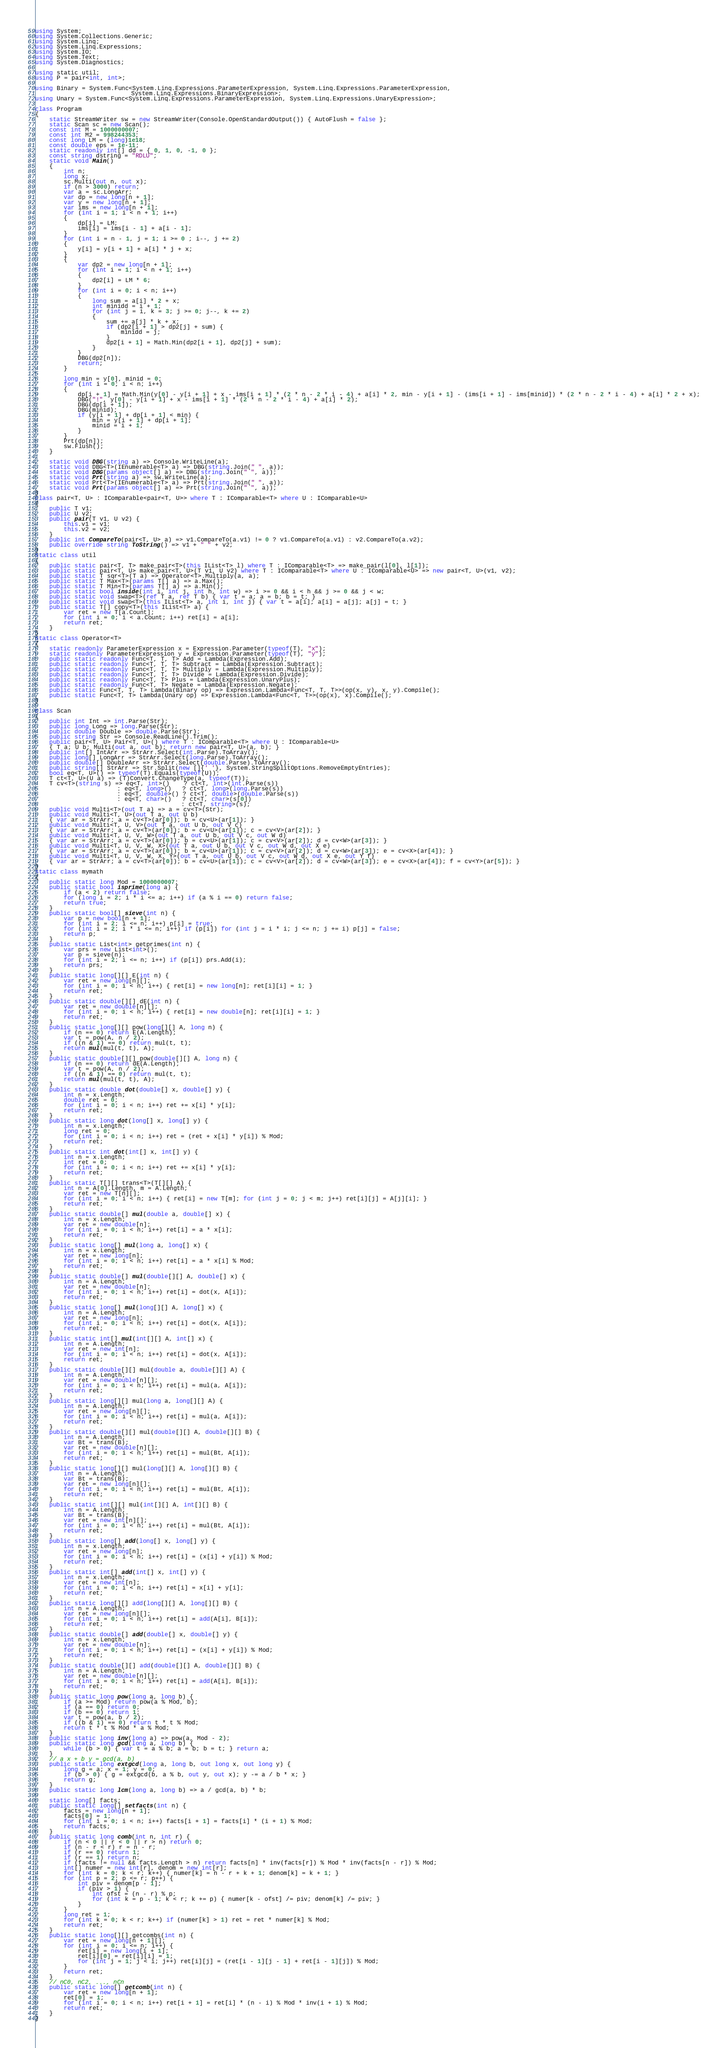<code> <loc_0><loc_0><loc_500><loc_500><_C#_>using System;
using System.Collections.Generic;
using System.Linq;
using System.Linq.Expressions;
using System.IO;
using System.Text;
using System.Diagnostics;

using static util;
using P = pair<int, int>;

using Binary = System.Func<System.Linq.Expressions.ParameterExpression, System.Linq.Expressions.ParameterExpression,
                           System.Linq.Expressions.BinaryExpression>;
using Unary = System.Func<System.Linq.Expressions.ParameterExpression, System.Linq.Expressions.UnaryExpression>;

class Program
{
    static StreamWriter sw = new StreamWriter(Console.OpenStandardOutput()) { AutoFlush = false };
    static Scan sc = new Scan();
    const int M = 1000000007;
    const int M2 = 998244353;
    const long LM = (long)1e18;
    const double eps = 1e-11;
    static readonly int[] dd = { 0, 1, 0, -1, 0 };
    const string dstring = "RDLU";
    static void Main()
    {
        int n;
        long x;
        sc.Multi(out n, out x);
        if (n > 3000) return;
        var a = sc.LongArr;
        var dp = new long[n + 1];
        var y = new long[n + 1];
        var ims = new long[n + 1];
        for (int i = 1; i < n + 1; i++)
        {
            dp[i] = LM;
            ims[i] = ims[i - 1] + a[i - 1];
        }
        for (int i = n - 1, j = 1; i >= 0 ; i--, j += 2)
        {
            y[i] = y[i + 1] + a[i] * j + x;
        }
        {
            var dp2 = new long[n + 1];
            for (int i = 1; i < n + 1; i++)
            {
                dp2[i] = LM * 6;
            }
            for (int i = 0; i < n; i++)
            {
                long sum = a[i] * 2 + x;
                int minidd = i + 1;
                for (int j = i, k = 3; j >= 0; j--, k += 2)
                {
                    sum += a[j] * k + x;
                    if (dp2[i + 1] > dp2[j] + sum) {
                        minidd = j;
                    }
                    dp2[i + 1] = Math.Min(dp2[i + 1], dp2[j] + sum);
                }
            }
            DBG(dp2[n]);
            return;
        }

        long min = y[0], minid = 0;
        for (int i = 0; i < n; i++)
        {
            dp[i + 1] = Math.Min(y[0] - y[i + 1] + x - ims[i + 1] * (2 * n - 2 * i - 4) + a[i] * 2, min - y[i + 1] - (ims[i + 1] - ims[minid]) * (2 * n - 2 * i - 4) + a[i] * 2 + x);
            DBG("!", y[0] - y[i + 1] + x - ims[i + 1] * (2 * n - 2 * i - 4) + a[i] * 2);
            DBG(dp[i + 1]);
            DBG(minid);
            if (y[i + 1] + dp[i + 1] < min) {
                min = y[i + 1] + dp[i + 1];
                minid = i + 1;
            }
        }
        Prt(dp[n]);
        sw.Flush();
    }

    static void DBG(string a) => Console.WriteLine(a);
    static void DBG<T>(IEnumerable<T> a) => DBG(string.Join(" ", a));
    static void DBG(params object[] a) => DBG(string.Join(" ", a));
    static void Prt(string a) => sw.WriteLine(a);
    static void Prt<T>(IEnumerable<T> a) => Prt(string.Join(" ", a));
    static void Prt(params object[] a) => Prt(string.Join(" ", a));
}
class pair<T, U> : IComparable<pair<T, U>> where T : IComparable<T> where U : IComparable<U>
{
    public T v1;
    public U v2;
    public pair(T v1, U v2) {
        this.v1 = v1;
        this.v2 = v2;
    }
    public int CompareTo(pair<T, U> a) => v1.CompareTo(a.v1) != 0 ? v1.CompareTo(a.v1) : v2.CompareTo(a.v2);
    public override string ToString() => v1 + " " + v2;
}
static class util
{
    public static pair<T, T> make_pair<T>(this IList<T> l) where T : IComparable<T> => make_pair(l[0], l[1]);
    public static pair<T, U> make_pair<T, U>(T v1, U v2) where T : IComparable<T> where U : IComparable<U> => new pair<T, U>(v1, v2);
    public static T sqr<T>(T a) => Operator<T>.Multiply(a, a);
    public static T Max<T>(params T[] a) => a.Max();
    public static T Min<T>(params T[] a) => a.Min();
    public static bool inside(int i, int j, int h, int w) => i >= 0 && i < h && j >= 0 && j < w;
    public static void swap<T>(ref T a, ref T b) { var t = a; a = b; b = t; }
    public static void swap<T>(this IList<T> a, int i, int j) { var t = a[i]; a[i] = a[j]; a[j] = t; }
    public static T[] copy<T>(this IList<T> a) {
        var ret = new T[a.Count];
        for (int i = 0; i < a.Count; i++) ret[i] = a[i];
        return ret;
    }
}
static class Operator<T>
{
    static readonly ParameterExpression x = Expression.Parameter(typeof(T), "x");
    static readonly ParameterExpression y = Expression.Parameter(typeof(T), "y");
    public static readonly Func<T, T, T> Add = Lambda(Expression.Add);
    public static readonly Func<T, T, T> Subtract = Lambda(Expression.Subtract);
    public static readonly Func<T, T, T> Multiply = Lambda(Expression.Multiply);
    public static readonly Func<T, T, T> Divide = Lambda(Expression.Divide);
    public static readonly Func<T, T> Plus = Lambda(Expression.UnaryPlus);
    public static readonly Func<T, T> Negate = Lambda(Expression.Negate);
    public static Func<T, T, T> Lambda(Binary op) => Expression.Lambda<Func<T, T, T>>(op(x, y), x, y).Compile();
    public static Func<T, T> Lambda(Unary op) => Expression.Lambda<Func<T, T>>(op(x), x).Compile();
}

class Scan
{
    public int Int => int.Parse(Str);
    public long Long => long.Parse(Str);
    public double Double => double.Parse(Str);
    public string Str => Console.ReadLine().Trim();
    public pair<T, U> Pair<T, U>() where T : IComparable<T> where U : IComparable<U>
    { T a; U b; Multi(out a, out b); return new pair<T, U>(a, b); }
    public int[] IntArr => StrArr.Select(int.Parse).ToArray();
    public long[] LongArr => StrArr.Select(long.Parse).ToArray();
    public double[] DoubleArr => StrArr.Select(double.Parse).ToArray();
    public string[] StrArr => Str.Split(new []{' '}, System.StringSplitOptions.RemoveEmptyEntries);
    bool eq<T, U>() => typeof(T).Equals(typeof(U));
    T ct<T, U>(U a) => (T)Convert.ChangeType(a, typeof(T));
    T cv<T>(string s) => eq<T, int>()    ? ct<T, int>(int.Parse(s))
                       : eq<T, long>()   ? ct<T, long>(long.Parse(s))
                       : eq<T, double>() ? ct<T, double>(double.Parse(s))
                       : eq<T, char>()   ? ct<T, char>(s[0])
                                         : ct<T, string>(s);
    public void Multi<T>(out T a) => a = cv<T>(Str);
    public void Multi<T, U>(out T a, out U b)
    { var ar = StrArr; a = cv<T>(ar[0]); b = cv<U>(ar[1]); }
    public void Multi<T, U, V>(out T a, out U b, out V c)
    { var ar = StrArr; a = cv<T>(ar[0]); b = cv<U>(ar[1]); c = cv<V>(ar[2]); }
    public void Multi<T, U, V, W>(out T a, out U b, out V c, out W d)
    { var ar = StrArr; a = cv<T>(ar[0]); b = cv<U>(ar[1]); c = cv<V>(ar[2]); d = cv<W>(ar[3]); }
    public void Multi<T, U, V, W, X>(out T a, out U b, out V c, out W d, out X e)
    { var ar = StrArr; a = cv<T>(ar[0]); b = cv<U>(ar[1]); c = cv<V>(ar[2]); d = cv<W>(ar[3]); e = cv<X>(ar[4]); }
    public void Multi<T, U, V, W, X, Y>(out T a, out U b, out V c, out W d, out X e, out Y f)
    { var ar = StrArr; a = cv<T>(ar[0]); b = cv<U>(ar[1]); c = cv<V>(ar[2]); d = cv<W>(ar[3]); e = cv<X>(ar[4]); f = cv<Y>(ar[5]); }
}
static class mymath
{
    public static long Mod = 1000000007;
    public static bool isprime(long a) {
        if (a < 2) return false;
        for (long i = 2; i * i <= a; i++) if (a % i == 0) return false;
        return true;
    }
    public static bool[] sieve(int n) {
        var p = new bool[n + 1];
        for (int i = 2; i <= n; i++) p[i] = true;
        for (int i = 2; i * i <= n; i++) if (p[i]) for (int j = i * i; j <= n; j += i) p[j] = false;
        return p;
    }
    public static List<int> getprimes(int n) {
        var prs = new List<int>();
        var p = sieve(n);
        for (int i = 2; i <= n; i++) if (p[i]) prs.Add(i);
        return prs;
    }
    public static long[][] E(int n) {
        var ret = new long[n][];
        for (int i = 0; i < n; i++) { ret[i] = new long[n]; ret[i][i] = 1; }
        return ret;
    }
    public static double[][] dE(int n) {
        var ret = new double[n][];
        for (int i = 0; i < n; i++) { ret[i] = new double[n]; ret[i][i] = 1; }
        return ret;
    }
    public static long[][] pow(long[][] A, long n) {
        if (n == 0) return E(A.Length);
        var t = pow(A, n / 2);
        if ((n & 1) == 0) return mul(t, t);
        return mul(mul(t, t), A);
    }
    public static double[][] pow(double[][] A, long n) {
        if (n == 0) return dE(A.Length);
        var t = pow(A, n / 2);
        if ((n & 1) == 0) return mul(t, t);
        return mul(mul(t, t), A);
    }
    public static double dot(double[] x, double[] y) {
        int n = x.Length;
        double ret = 0;
        for (int i = 0; i < n; i++) ret += x[i] * y[i];
        return ret;
    }
    public static long dot(long[] x, long[] y) {
        int n = x.Length;
        long ret = 0;
        for (int i = 0; i < n; i++) ret = (ret + x[i] * y[i]) % Mod;
        return ret;
    }
    public static int dot(int[] x, int[] y) {
        int n = x.Length;
        int ret = 0;
        for (int i = 0; i < n; i++) ret += x[i] * y[i];
        return ret;
    }
    public static T[][] trans<T>(T[][] A) {
        int n = A[0].Length, m = A.Length;
        var ret = new T[n][];
        for (int i = 0; i < n; i++) { ret[i] = new T[m]; for (int j = 0; j < m; j++) ret[i][j] = A[j][i]; }
        return ret;
    }
    public static double[] mul(double a, double[] x) {
        int n = x.Length;
        var ret = new double[n];
        for (int i = 0; i < n; i++) ret[i] = a * x[i];
        return ret;
    }
    public static long[] mul(long a, long[] x) {
        int n = x.Length;
        var ret = new long[n];
        for (int i = 0; i < n; i++) ret[i] = a * x[i] % Mod;
        return ret;
    }
    public static double[] mul(double[][] A, double[] x) {
        int n = A.Length;
        var ret = new double[n];
        for (int i = 0; i < n; i++) ret[i] = dot(x, A[i]);
        return ret;
    }
    public static long[] mul(long[][] A, long[] x) {
        int n = A.Length;
        var ret = new long[n];
        for (int i = 0; i < n; i++) ret[i] = dot(x, A[i]);
        return ret;
    }
    public static int[] mul(int[][] A, int[] x) {
        int n = A.Length;
        var ret = new int[n];
        for (int i = 0; i < n; i++) ret[i] = dot(x, A[i]);
        return ret;
    }
    public static double[][] mul(double a, double[][] A) {
        int n = A.Length;
        var ret = new double[n][];
        for (int i = 0; i < n; i++) ret[i] = mul(a, A[i]);
        return ret;
    }
    public static long[][] mul(long a, long[][] A) {
        int n = A.Length;
        var ret = new long[n][];
        for (int i = 0; i < n; i++) ret[i] = mul(a, A[i]);
        return ret;
    }
    public static double[][] mul(double[][] A, double[][] B) {
        int n = A.Length;
        var Bt = trans(B);
        var ret = new double[n][];
        for (int i = 0; i < n; i++) ret[i] = mul(Bt, A[i]);
        return ret;
    }
    public static long[][] mul(long[][] A, long[][] B) {
        int n = A.Length;
        var Bt = trans(B);
        var ret = new long[n][];
        for (int i = 0; i < n; i++) ret[i] = mul(Bt, A[i]);
        return ret;
    }
    public static int[][] mul(int[][] A, int[][] B) {
        int n = A.Length;
        var Bt = trans(B);
        var ret = new int[n][];
        for (int i = 0; i < n; i++) ret[i] = mul(Bt, A[i]);
        return ret;
    }
    public static long[] add(long[] x, long[] y) {
        int n = x.Length;
        var ret = new long[n];
        for (int i = 0; i < n; i++) ret[i] = (x[i] + y[i]) % Mod;
        return ret;
    }
    public static int[] add(int[] x, int[] y) {
        int n = x.Length;
        var ret = new int[n];
        for (int i = 0; i < n; i++) ret[i] = x[i] + y[i];
        return ret;
    }
    public static long[][] add(long[][] A, long[][] B) {
        int n = A.Length;
        var ret = new long[n][];
        for (int i = 0; i < n; i++) ret[i] = add(A[i], B[i]);
        return ret;
    }
    public static double[] add(double[] x, double[] y) {
        int n = x.Length;
        var ret = new double[n];
        for (int i = 0; i < n; i++) ret[i] = (x[i] + y[i]) % Mod;
        return ret;
    }
    public static double[][] add(double[][] A, double[][] B) {
        int n = A.Length;
        var ret = new double[n][];
        for (int i = 0; i < n; i++) ret[i] = add(A[i], B[i]);
        return ret;
    }
    public static long pow(long a, long b) {
        if (a >= Mod) return pow(a % Mod, b);
        if (a == 0) return 0;
        if (b == 0) return 1;
        var t = pow(a, b / 2);
        if ((b & 1) == 0) return t * t % Mod;
        return t * t % Mod * a % Mod;
    }
    public static long inv(long a) => pow(a, Mod - 2);
    public static long gcd(long a, long b) {
        while (b > 0) { var t = a % b; a = b; b = t; } return a;
    }
    // a x + b y = gcd(a, b)
    public static long extgcd(long a, long b, out long x, out long y) {
        long g = a; x = 1; y = 0;
        if (b > 0) { g = extgcd(b, a % b, out y, out x); y -= a / b * x; }
        return g;
    }
    public static long lcm(long a, long b) => a / gcd(a, b) * b;

    static long[] facts;
    public static long[] setfacts(int n) {
        facts = new long[n + 1];
        facts[0] = 1;
        for (int i = 0; i < n; i++) facts[i + 1] = facts[i] * (i + 1) % Mod;
        return facts;
    }
    public static long comb(int n, int r) {
        if (n < 0 || r < 0 || r > n) return 0;
        if (n - r < r) r = n - r;
        if (r == 0) return 1;
        if (r == 1) return n;
        if (facts != null && facts.Length > n) return facts[n] * inv(facts[r]) % Mod * inv(facts[n - r]) % Mod;
        int[] numer = new int[r], denom = new int[r];
        for (int k = 0; k < r; k++) { numer[k] = n - r + k + 1; denom[k] = k + 1; }
        for (int p = 2; p <= r; p++) {
            int piv = denom[p - 1];
            if (piv > 1) {
                int ofst = (n - r) % p;
                for (int k = p - 1; k < r; k += p) { numer[k - ofst] /= piv; denom[k] /= piv; }
            }
        }
        long ret = 1;
        for (int k = 0; k < r; k++) if (numer[k] > 1) ret = ret * numer[k] % Mod;
        return ret;
    }
    public static long[][] getcombs(int n) {
        var ret = new long[n + 1][];
        for (int i = 0; i <= n; i++) {
            ret[i] = new long[i + 1];
            ret[i][0] = ret[i][i] = 1;
            for (int j = 1; j < i; j++) ret[i][j] = (ret[i - 1][j - 1] + ret[i - 1][j]) % Mod;
        }
        return ret;
    }
    // nC0, nC2, ..., nCn
    public static long[] getcomb(int n) {
        var ret = new long[n + 1];
        ret[0] = 1;
        for (int i = 0; i < n; i++) ret[i + 1] = ret[i] * (n - i) % Mod * inv(i + 1) % Mod;
        return ret;
    }
}
</code> 